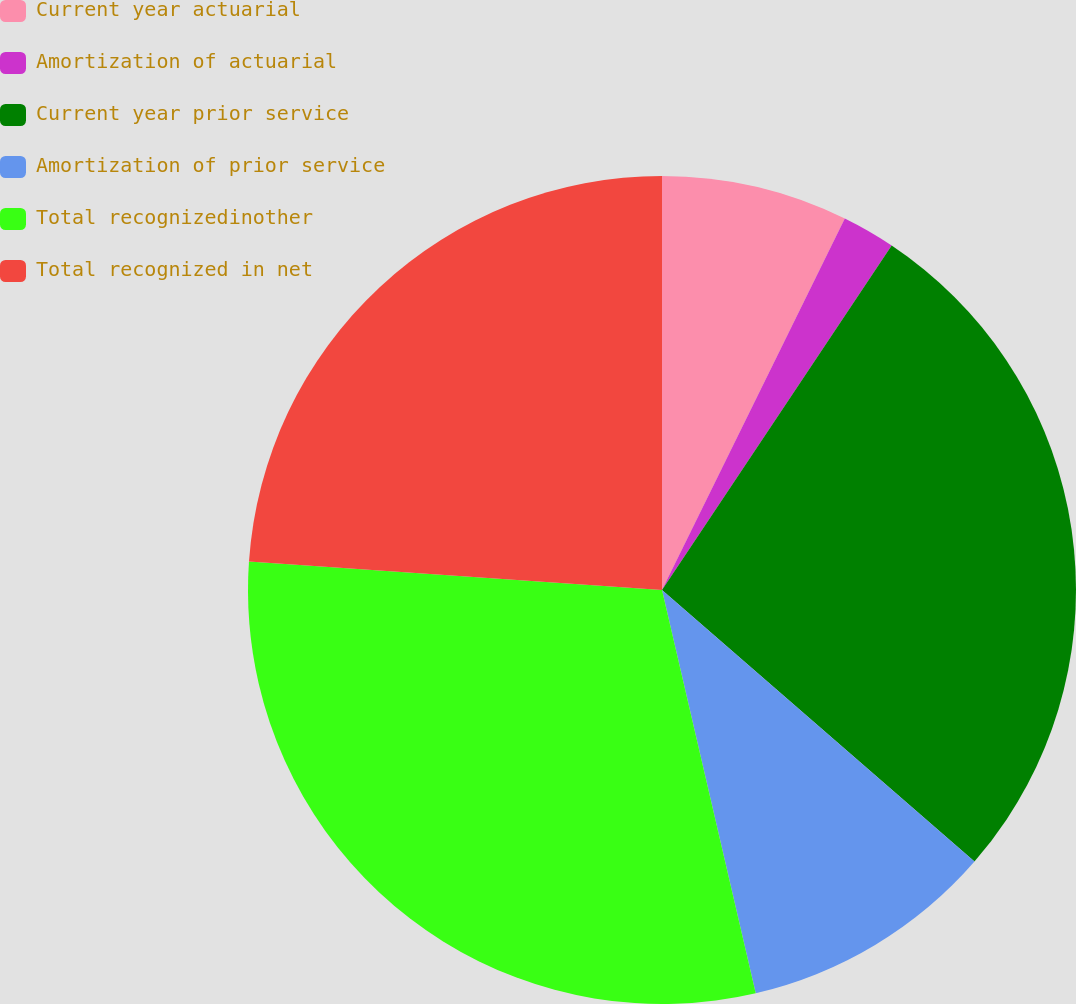Convert chart to OTSL. <chart><loc_0><loc_0><loc_500><loc_500><pie_chart><fcel>Current year actuarial<fcel>Amortization of actuarial<fcel>Current year prior service<fcel>Amortization of prior service<fcel>Total recognizedinother<fcel>Total recognized in net<nl><fcel>7.28%<fcel>2.08%<fcel>27.03%<fcel>9.98%<fcel>29.73%<fcel>23.91%<nl></chart> 